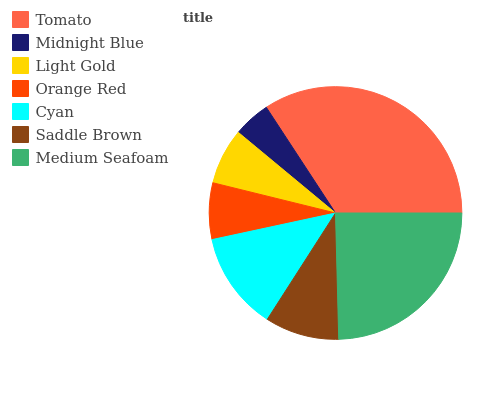Is Midnight Blue the minimum?
Answer yes or no. Yes. Is Tomato the maximum?
Answer yes or no. Yes. Is Light Gold the minimum?
Answer yes or no. No. Is Light Gold the maximum?
Answer yes or no. No. Is Light Gold greater than Midnight Blue?
Answer yes or no. Yes. Is Midnight Blue less than Light Gold?
Answer yes or no. Yes. Is Midnight Blue greater than Light Gold?
Answer yes or no. No. Is Light Gold less than Midnight Blue?
Answer yes or no. No. Is Saddle Brown the high median?
Answer yes or no. Yes. Is Saddle Brown the low median?
Answer yes or no. Yes. Is Orange Red the high median?
Answer yes or no. No. Is Cyan the low median?
Answer yes or no. No. 